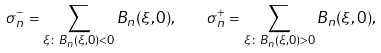Convert formula to latex. <formula><loc_0><loc_0><loc_500><loc_500>\sigma _ { n } ^ { - } = \sum _ { \xi \colon B _ { n } ( \xi , 0 ) < 0 } B _ { n } ( \xi , 0 ) , \quad \sigma _ { n } ^ { + } = \sum _ { \xi \colon B _ { n } ( \xi , 0 ) > 0 } B _ { n } ( \xi , 0 ) ,</formula> 